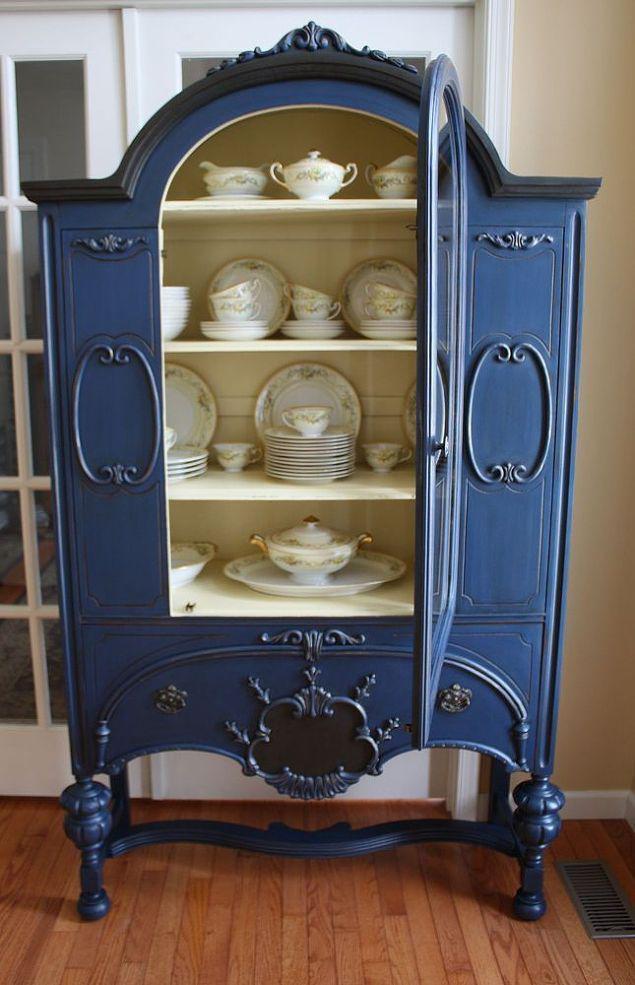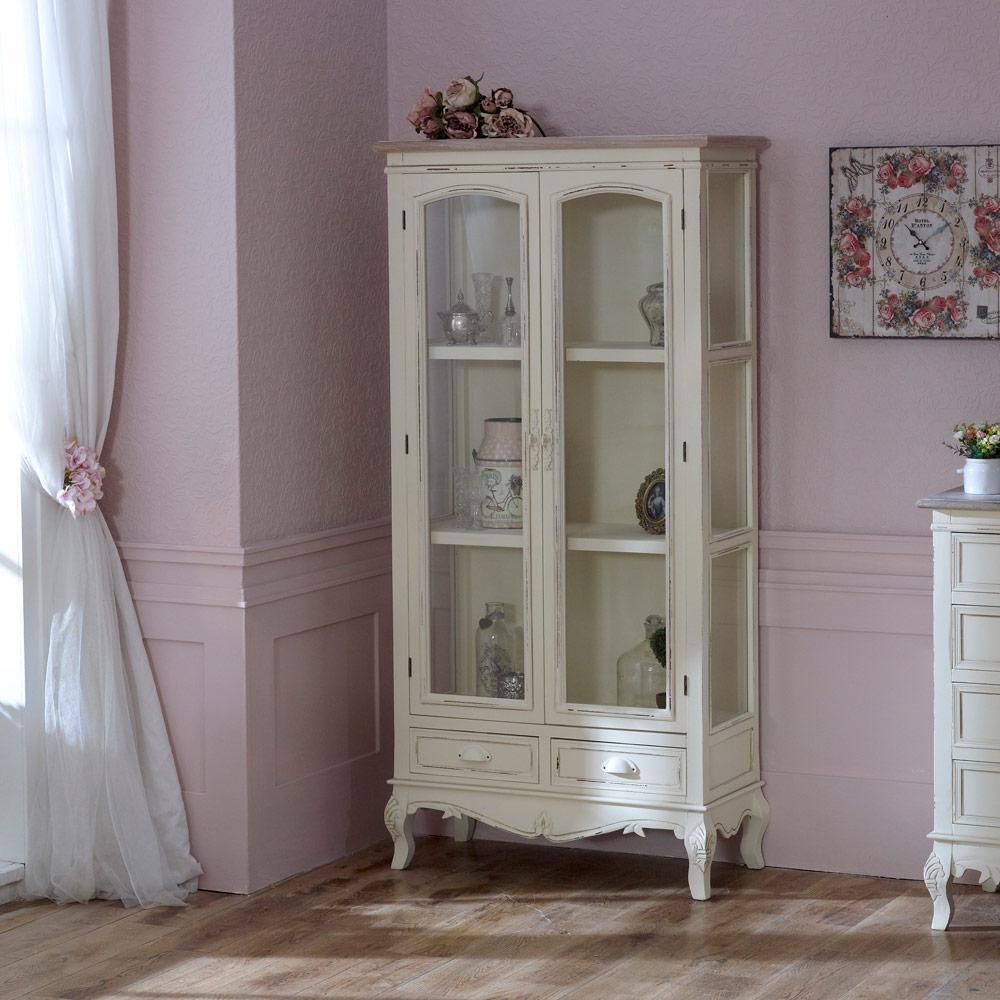The first image is the image on the left, the second image is the image on the right. Analyze the images presented: Is the assertion "The cabinet on the right is set up against a pink wall." valid? Answer yes or no. Yes. The first image is the image on the left, the second image is the image on the right. Considering the images on both sides, is "One wooden hutch has a pair of doors and flat top, while the other has a single centered glass door and rounded decorative detail at the top." valid? Answer yes or no. Yes. 